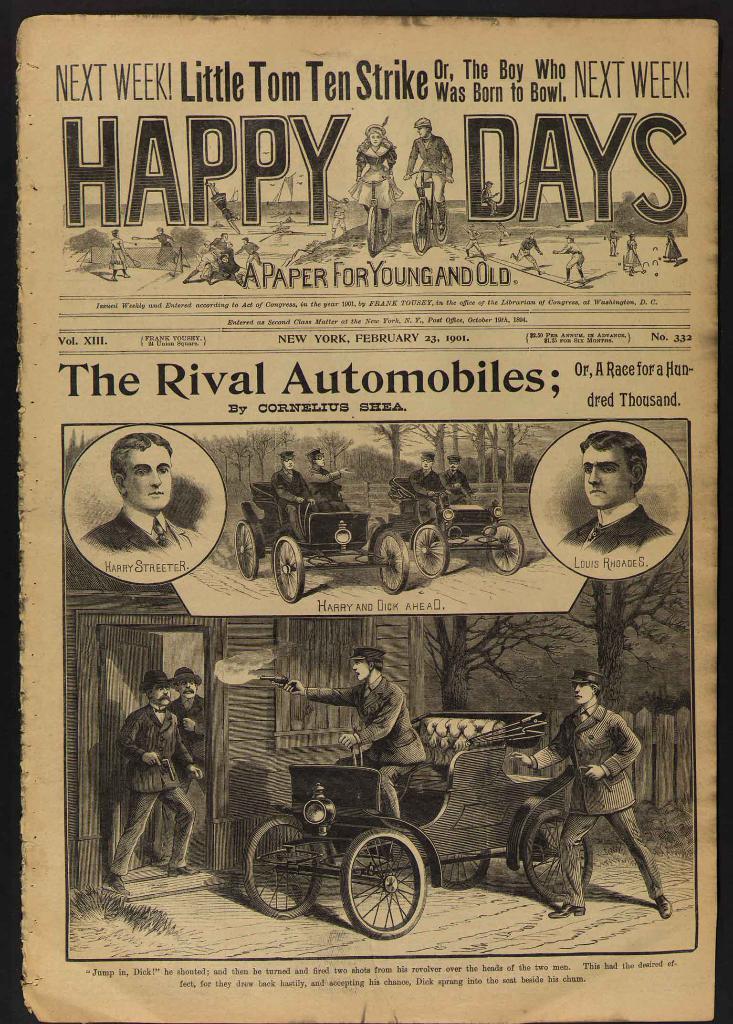Describe this image in one or two sentences. In this image I can see a poster. On the poster I can see photos of vehicles and people. I can also see something written on it. 